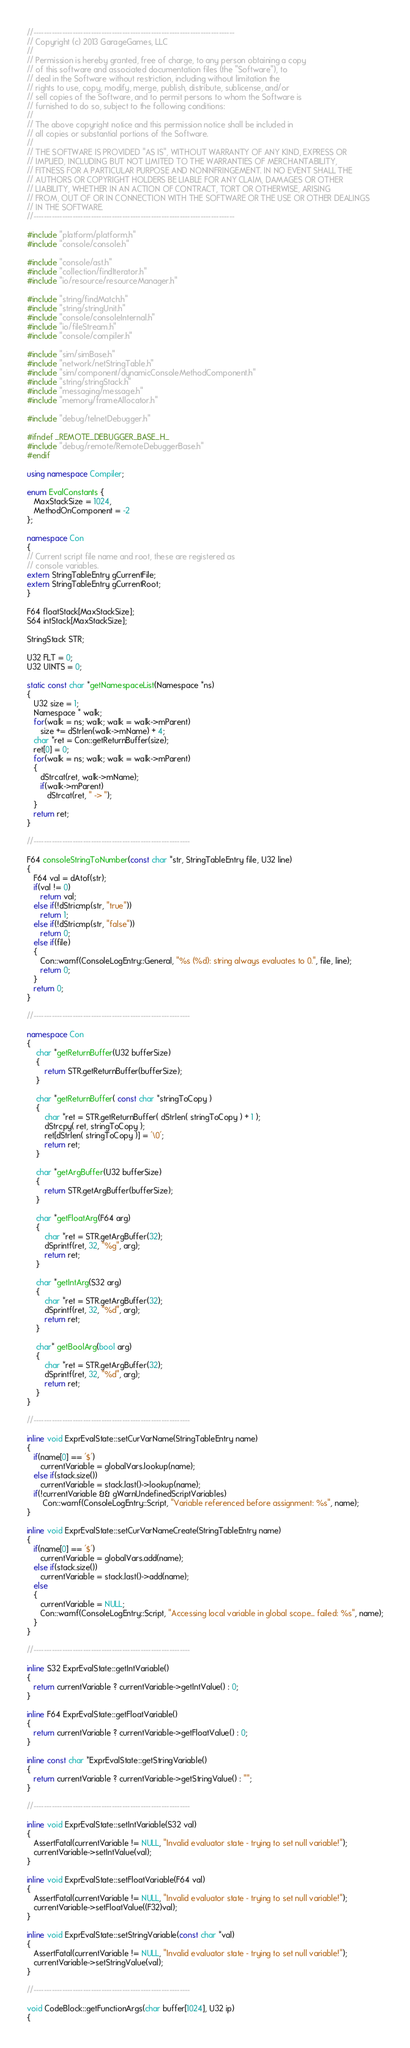Convert code to text. <code><loc_0><loc_0><loc_500><loc_500><_C++_>//-----------------------------------------------------------------------------
// Copyright (c) 2013 GarageGames, LLC
//
// Permission is hereby granted, free of charge, to any person obtaining a copy
// of this software and associated documentation files (the "Software"), to
// deal in the Software without restriction, including without limitation the
// rights to use, copy, modify, merge, publish, distribute, sublicense, and/or
// sell copies of the Software, and to permit persons to whom the Software is
// furnished to do so, subject to the following conditions:
//
// The above copyright notice and this permission notice shall be included in
// all copies or substantial portions of the Software.
//
// THE SOFTWARE IS PROVIDED "AS IS", WITHOUT WARRANTY OF ANY KIND, EXPRESS OR
// IMPLIED, INCLUDING BUT NOT LIMITED TO THE WARRANTIES OF MERCHANTABILITY,
// FITNESS FOR A PARTICULAR PURPOSE AND NONINFRINGEMENT. IN NO EVENT SHALL THE
// AUTHORS OR COPYRIGHT HOLDERS BE LIABLE FOR ANY CLAIM, DAMAGES OR OTHER
// LIABILITY, WHETHER IN AN ACTION OF CONTRACT, TORT OR OTHERWISE, ARISING
// FROM, OUT OF OR IN CONNECTION WITH THE SOFTWARE OR THE USE OR OTHER DEALINGS
// IN THE SOFTWARE.
//-----------------------------------------------------------------------------

#include "platform/platform.h"
#include "console/console.h"

#include "console/ast.h"
#include "collection/findIterator.h"
#include "io/resource/resourceManager.h"

#include "string/findMatch.h"
#include "string/stringUnit.h"
#include "console/consoleInternal.h"
#include "io/fileStream.h"
#include "console/compiler.h"

#include "sim/simBase.h"
#include "network/netStringTable.h"
#include "sim/component/dynamicConsoleMethodComponent.h"
#include "string/stringStack.h"
#include "messaging/message.h"
#include "memory/frameAllocator.h"

#include "debug/telnetDebugger.h"

#ifndef _REMOTE_DEBUGGER_BASE_H_
#include "debug/remote/RemoteDebuggerBase.h"
#endif

using namespace Compiler;

enum EvalConstants {
   MaxStackSize = 1024,
   MethodOnComponent = -2
};

namespace Con
{
// Current script file name and root, these are registered as
// console variables.
extern StringTableEntry gCurrentFile;
extern StringTableEntry gCurrentRoot;
}

F64 floatStack[MaxStackSize];
S64 intStack[MaxStackSize];

StringStack STR;

U32 FLT = 0;
U32 UINTS = 0;

static const char *getNamespaceList(Namespace *ns)
{
   U32 size = 1;
   Namespace * walk;
   for(walk = ns; walk; walk = walk->mParent)
      size += dStrlen(walk->mName) + 4;
   char *ret = Con::getReturnBuffer(size);
   ret[0] = 0;
   for(walk = ns; walk; walk = walk->mParent)
   {
      dStrcat(ret, walk->mName);
      if(walk->mParent)
         dStrcat(ret, " -> ");
   }
   return ret;
}

//------------------------------------------------------------

F64 consoleStringToNumber(const char *str, StringTableEntry file, U32 line)
{
   F64 val = dAtof(str);
   if(val != 0)
      return val;
   else if(!dStricmp(str, "true"))
      return 1;
   else if(!dStricmp(str, "false"))
      return 0;
   else if(file)
   {
      Con::warnf(ConsoleLogEntry::General, "%s (%d): string always evaluates to 0.", file, line);
      return 0;
   }
   return 0;
}

//------------------------------------------------------------

namespace Con
{
    char *getReturnBuffer(U32 bufferSize)
    {
        return STR.getReturnBuffer(bufferSize);
    }

    char *getReturnBuffer( const char *stringToCopy )
    {
        char *ret = STR.getReturnBuffer( dStrlen( stringToCopy ) + 1 );
        dStrcpy( ret, stringToCopy );
        ret[dStrlen( stringToCopy )] = '\0';
        return ret;
    }

    char *getArgBuffer(U32 bufferSize)
    {
        return STR.getArgBuffer(bufferSize);
    }

    char *getFloatArg(F64 arg)
    {
        char *ret = STR.getArgBuffer(32);
        dSprintf(ret, 32, "%g", arg);
        return ret;
    }

    char *getIntArg(S32 arg)
    {
        char *ret = STR.getArgBuffer(32);
        dSprintf(ret, 32, "%d", arg);
        return ret;
    }

    char* getBoolArg(bool arg)
    {
        char *ret = STR.getArgBuffer(32);
        dSprintf(ret, 32, "%d", arg);
        return ret;
    }
}

//------------------------------------------------------------

inline void ExprEvalState::setCurVarName(StringTableEntry name)
{
   if(name[0] == '$')
      currentVariable = globalVars.lookup(name);
   else if(stack.size())
      currentVariable = stack.last()->lookup(name);
   if(!currentVariable && gWarnUndefinedScriptVariables)
       Con::warnf(ConsoleLogEntry::Script, "Variable referenced before assignment: %s", name);
}

inline void ExprEvalState::setCurVarNameCreate(StringTableEntry name)
{
   if(name[0] == '$')
      currentVariable = globalVars.add(name);
   else if(stack.size())
      currentVariable = stack.last()->add(name);
   else
   {
      currentVariable = NULL;
      Con::warnf(ConsoleLogEntry::Script, "Accessing local variable in global scope... failed: %s", name);
   }
}

//------------------------------------------------------------

inline S32 ExprEvalState::getIntVariable()
{
   return currentVariable ? currentVariable->getIntValue() : 0;
}

inline F64 ExprEvalState::getFloatVariable()
{
   return currentVariable ? currentVariable->getFloatValue() : 0;
}

inline const char *ExprEvalState::getStringVariable()
{
   return currentVariable ? currentVariable->getStringValue() : "";
}

//------------------------------------------------------------

inline void ExprEvalState::setIntVariable(S32 val)
{
   AssertFatal(currentVariable != NULL, "Invalid evaluator state - trying to set null variable!");
   currentVariable->setIntValue(val);
}

inline void ExprEvalState::setFloatVariable(F64 val)
{
   AssertFatal(currentVariable != NULL, "Invalid evaluator state - trying to set null variable!");
   currentVariable->setFloatValue((F32)val);
}

inline void ExprEvalState::setStringVariable(const char *val)
{
   AssertFatal(currentVariable != NULL, "Invalid evaluator state - trying to set null variable!");
   currentVariable->setStringValue(val);
}

//------------------------------------------------------------

void CodeBlock::getFunctionArgs(char buffer[1024], U32 ip)
{</code> 